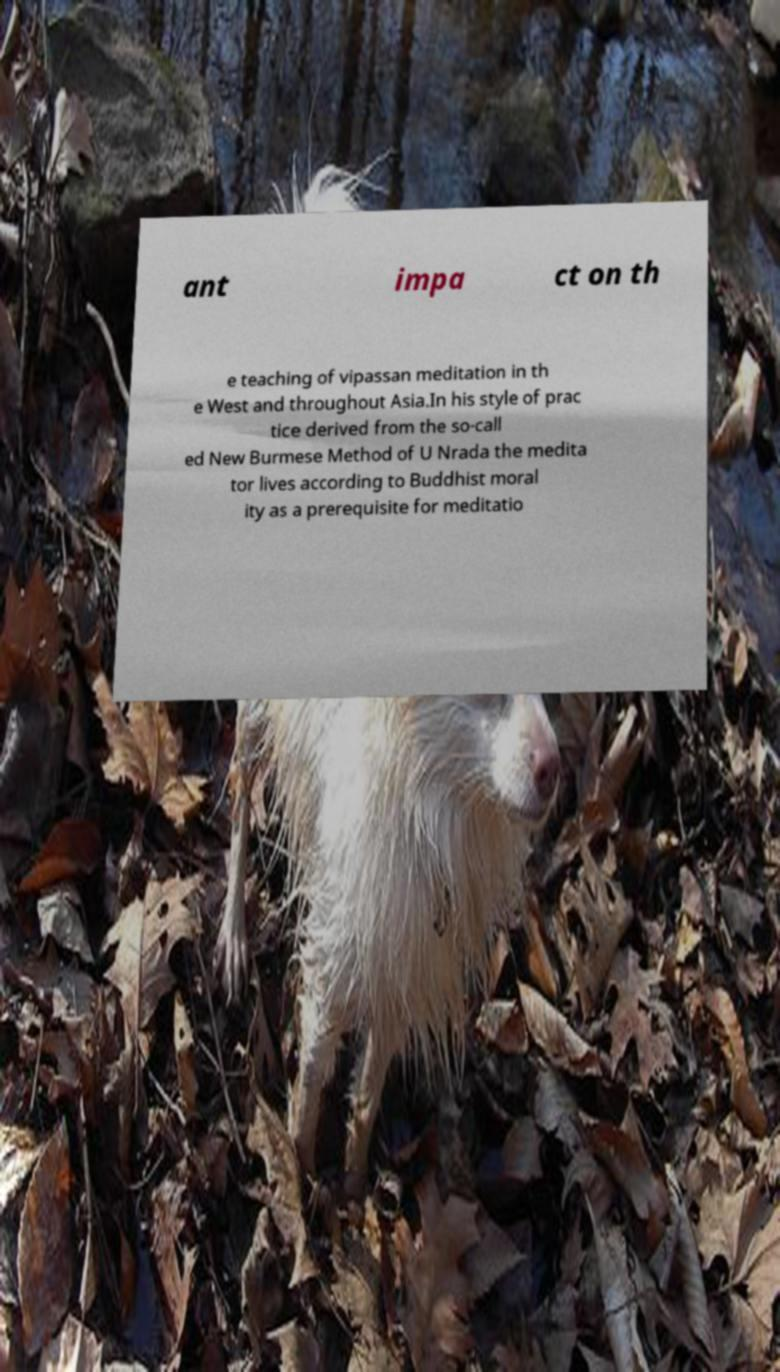What messages or text are displayed in this image? I need them in a readable, typed format. ant impa ct on th e teaching of vipassan meditation in th e West and throughout Asia.In his style of prac tice derived from the so-call ed New Burmese Method of U Nrada the medita tor lives according to Buddhist moral ity as a prerequisite for meditatio 